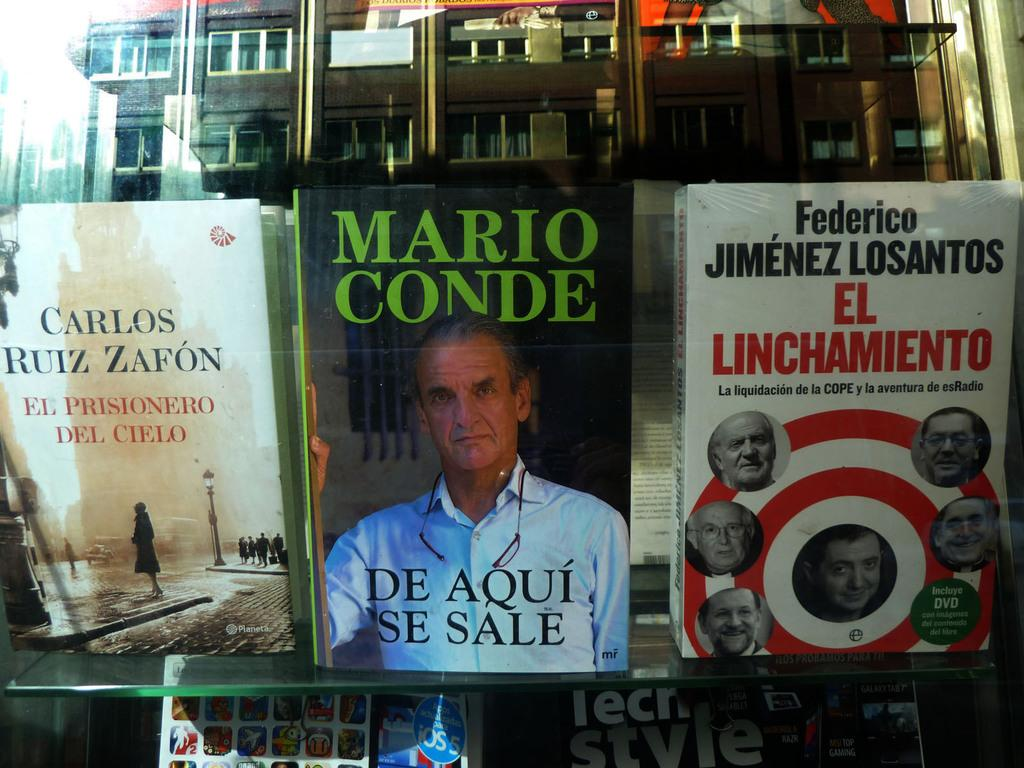<image>
Create a compact narrative representing the image presented. Several books on top of a bookshelf, with a book titled "De Aqui Se Sale" as the most prominent. 